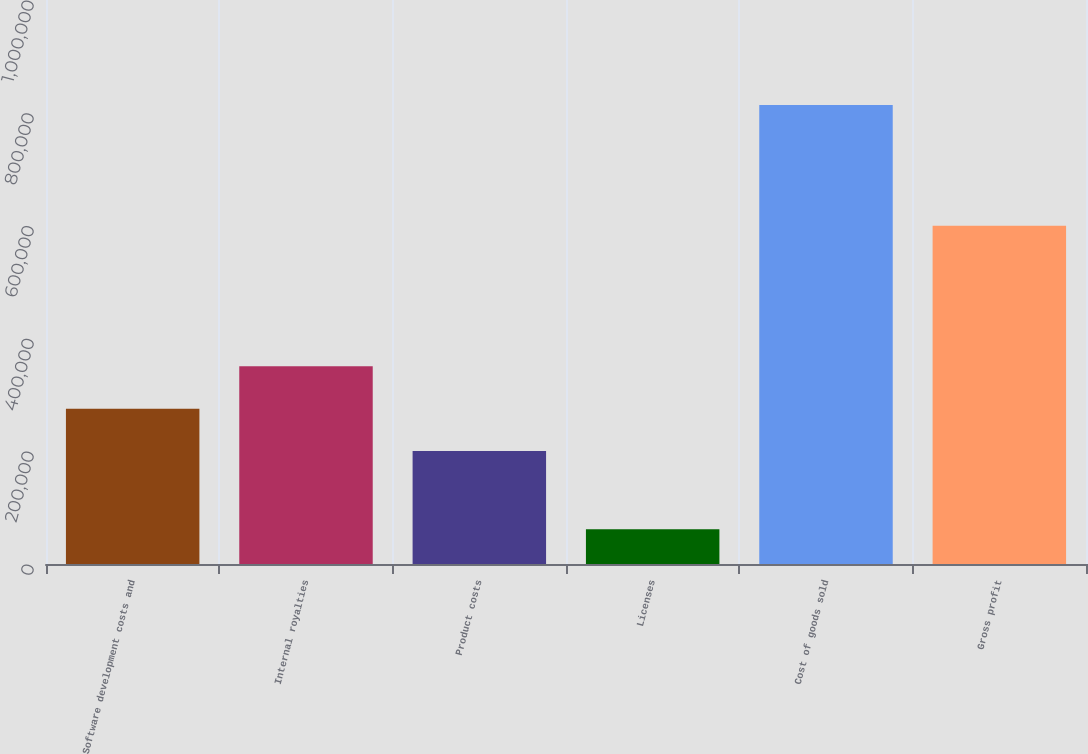<chart> <loc_0><loc_0><loc_500><loc_500><bar_chart><fcel>Software development costs and<fcel>Internal royalties<fcel>Product costs<fcel>Licenses<fcel>Cost of goods sold<fcel>Gross profit<nl><fcel>275439<fcel>350672<fcel>200206<fcel>61545<fcel>813873<fcel>599825<nl></chart> 